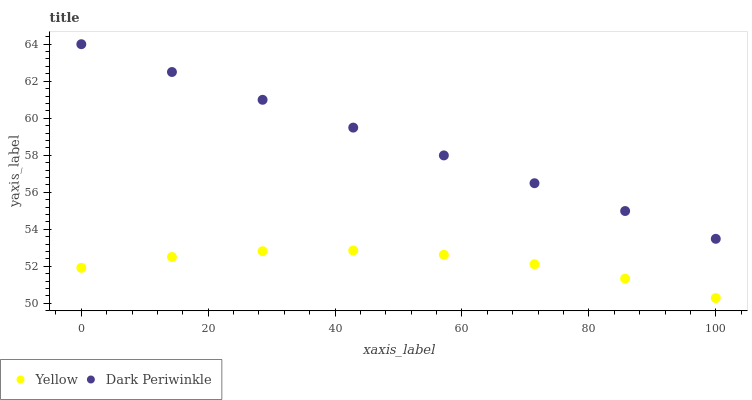Does Yellow have the minimum area under the curve?
Answer yes or no. Yes. Does Dark Periwinkle have the maximum area under the curve?
Answer yes or no. Yes. Does Yellow have the maximum area under the curve?
Answer yes or no. No. Is Dark Periwinkle the smoothest?
Answer yes or no. Yes. Is Yellow the roughest?
Answer yes or no. Yes. Is Yellow the smoothest?
Answer yes or no. No. Does Yellow have the lowest value?
Answer yes or no. Yes. Does Dark Periwinkle have the highest value?
Answer yes or no. Yes. Does Yellow have the highest value?
Answer yes or no. No. Is Yellow less than Dark Periwinkle?
Answer yes or no. Yes. Is Dark Periwinkle greater than Yellow?
Answer yes or no. Yes. Does Yellow intersect Dark Periwinkle?
Answer yes or no. No. 